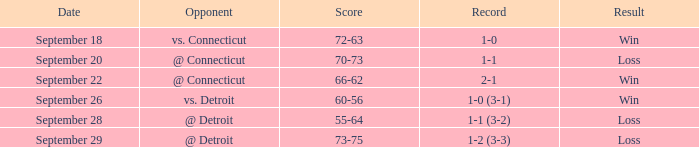WHAT IS THE RESULT WITH A SCORE OF 70-73? Loss. 